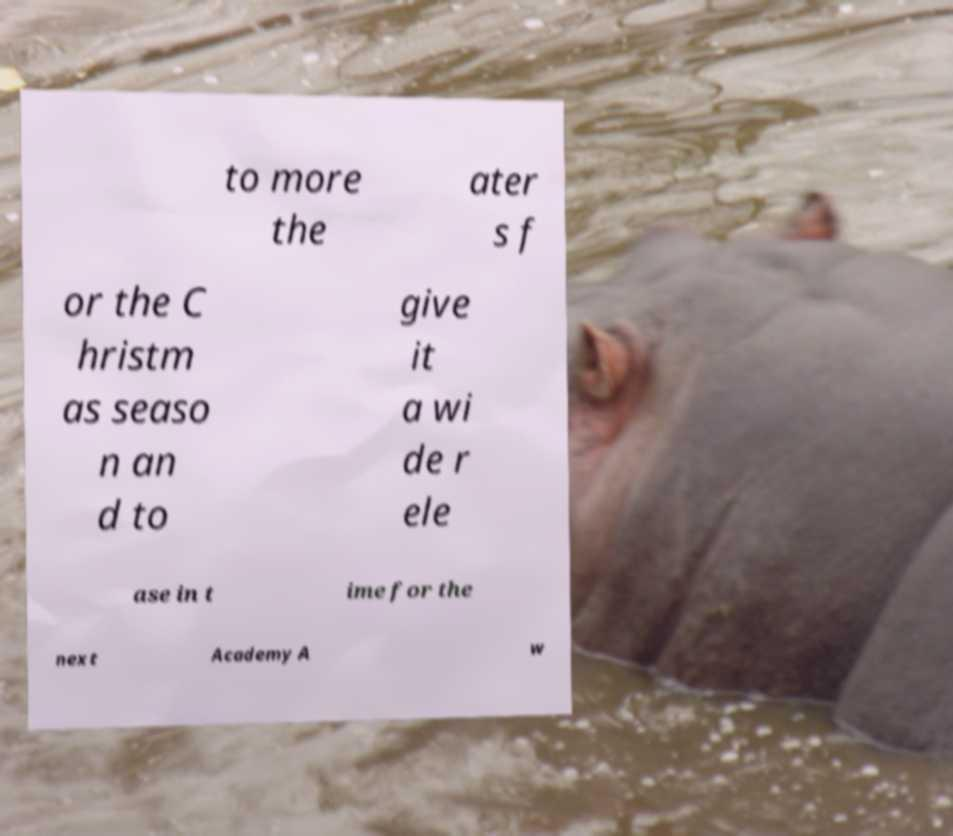Please identify and transcribe the text found in this image. to more the ater s f or the C hristm as seaso n an d to give it a wi de r ele ase in t ime for the next Academy A w 